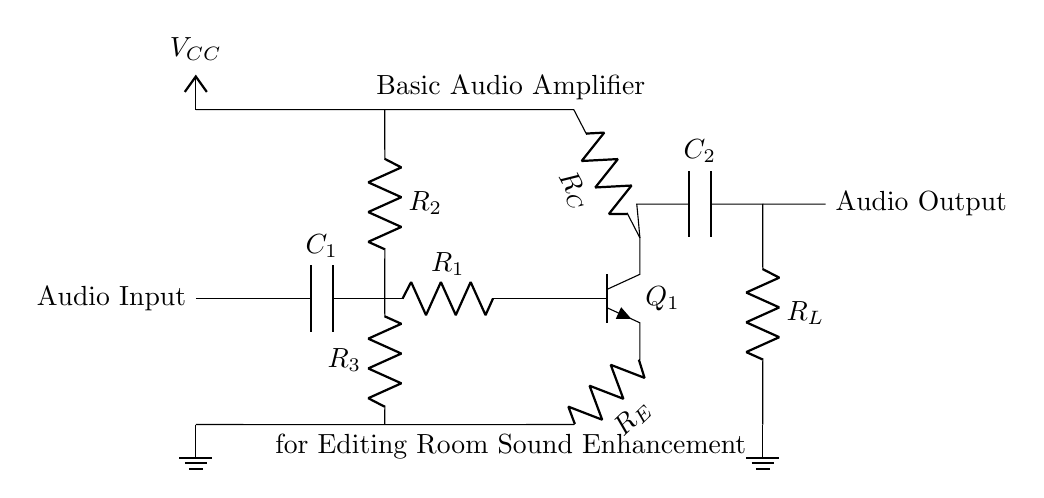What is the type of transistor used in this circuit? The circuit uses an NPN transistor, indicated by the label "npn" next to the symbol for the transistor.
Answer: NPN What is the function of the capacitor labeled C1? The capacitor C1 acts as a coupling capacitor, allowing AC signals to pass while blocking DC components from the audio input, which is common in audio amplifiers.
Answer: Coupling What are the values given for R2 and R3? The values for R2 and R3 are not explicitly provided in the diagram; they are represented simply as resistors without numerical labels, indicating their role in biasing but not their specific resistance values.
Answer: Not provided Which component is responsible for sound output? The sound output is taken from the audio output labeled in the circuit, which follows the capacitor C2 and the resistor RL.
Answer: Resistor RL What does the current flow from the audio input to the NPN transistor indicate? The current flow from the audio input through C1 and R1 to the NPN transistor Q1 indicates that the circuit is designed to amplify audio signals received, enhancing sound quality.
Answer: Sound amplification Which component provides the DC voltage supply for the circuit? The DC voltage supply is provided by the node labeled as VCC, which is connected to the collector of the transistor, thus powering the amplification stage.
Answer: VCC What is the purpose of the emitter resistor RE? The emitter resistor RE stabilizes the operating point by providing negative feedback in the transistor, helping to improve linearity and temperature stability.
Answer: Negative feedback 